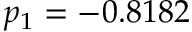<formula> <loc_0><loc_0><loc_500><loc_500>p _ { 1 } = - 0 . 8 1 8 2</formula> 